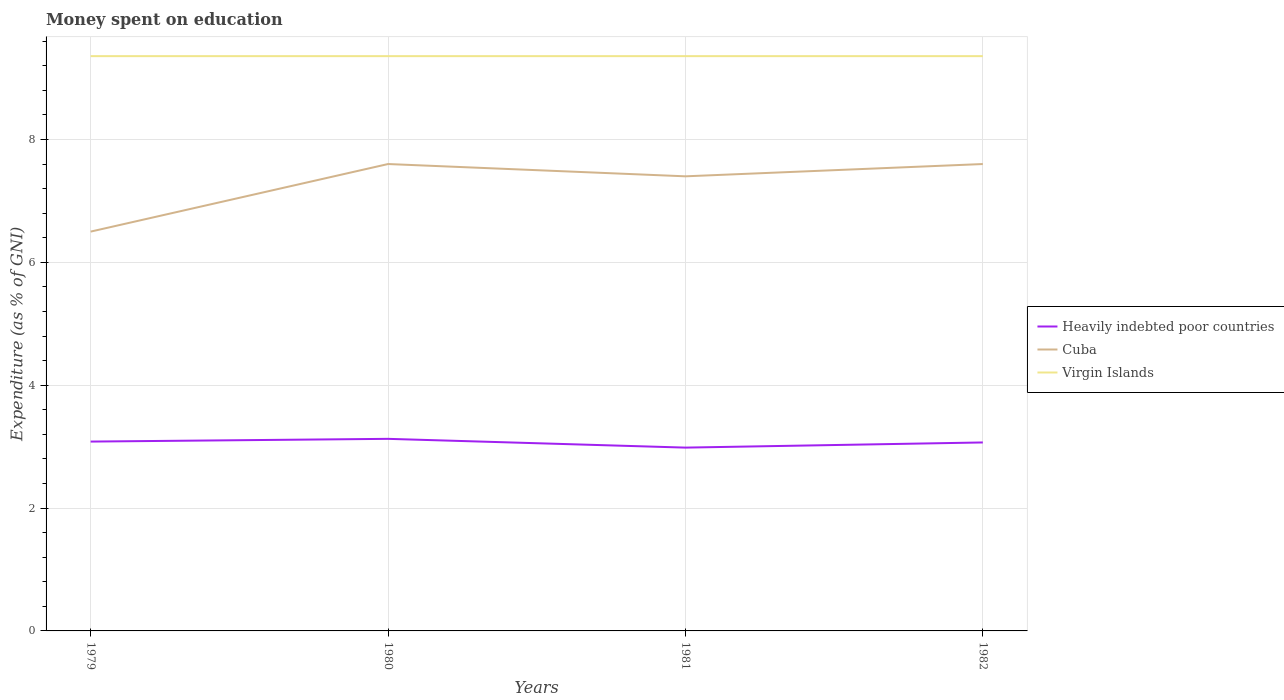What is the total amount of money spent on education in Heavily indebted poor countries in the graph?
Give a very brief answer. 0.14. Is the amount of money spent on education in Heavily indebted poor countries strictly greater than the amount of money spent on education in Cuba over the years?
Your answer should be compact. Yes. How many lines are there?
Your response must be concise. 3. How many years are there in the graph?
Make the answer very short. 4. What is the difference between two consecutive major ticks on the Y-axis?
Keep it short and to the point. 2. Does the graph contain grids?
Your answer should be compact. Yes. How are the legend labels stacked?
Your answer should be very brief. Vertical. What is the title of the graph?
Give a very brief answer. Money spent on education. Does "Bolivia" appear as one of the legend labels in the graph?
Ensure brevity in your answer.  No. What is the label or title of the X-axis?
Offer a very short reply. Years. What is the label or title of the Y-axis?
Your answer should be very brief. Expenditure (as % of GNI). What is the Expenditure (as % of GNI) in Heavily indebted poor countries in 1979?
Your answer should be compact. 3.08. What is the Expenditure (as % of GNI) of Virgin Islands in 1979?
Your response must be concise. 9.36. What is the Expenditure (as % of GNI) of Heavily indebted poor countries in 1980?
Your response must be concise. 3.13. What is the Expenditure (as % of GNI) in Cuba in 1980?
Your answer should be compact. 7.6. What is the Expenditure (as % of GNI) in Virgin Islands in 1980?
Provide a short and direct response. 9.36. What is the Expenditure (as % of GNI) of Heavily indebted poor countries in 1981?
Offer a terse response. 2.98. What is the Expenditure (as % of GNI) in Virgin Islands in 1981?
Give a very brief answer. 9.36. What is the Expenditure (as % of GNI) of Heavily indebted poor countries in 1982?
Provide a succinct answer. 3.07. What is the Expenditure (as % of GNI) of Virgin Islands in 1982?
Your answer should be compact. 9.36. Across all years, what is the maximum Expenditure (as % of GNI) in Heavily indebted poor countries?
Give a very brief answer. 3.13. Across all years, what is the maximum Expenditure (as % of GNI) in Cuba?
Offer a very short reply. 7.6. Across all years, what is the maximum Expenditure (as % of GNI) in Virgin Islands?
Make the answer very short. 9.36. Across all years, what is the minimum Expenditure (as % of GNI) in Heavily indebted poor countries?
Ensure brevity in your answer.  2.98. Across all years, what is the minimum Expenditure (as % of GNI) of Cuba?
Provide a short and direct response. 6.5. Across all years, what is the minimum Expenditure (as % of GNI) in Virgin Islands?
Your answer should be very brief. 9.36. What is the total Expenditure (as % of GNI) of Heavily indebted poor countries in the graph?
Offer a very short reply. 12.26. What is the total Expenditure (as % of GNI) of Cuba in the graph?
Provide a short and direct response. 29.1. What is the total Expenditure (as % of GNI) in Virgin Islands in the graph?
Provide a succinct answer. 37.42. What is the difference between the Expenditure (as % of GNI) in Heavily indebted poor countries in 1979 and that in 1980?
Provide a short and direct response. -0.04. What is the difference between the Expenditure (as % of GNI) in Cuba in 1979 and that in 1980?
Provide a short and direct response. -1.1. What is the difference between the Expenditure (as % of GNI) in Virgin Islands in 1979 and that in 1980?
Offer a terse response. 0. What is the difference between the Expenditure (as % of GNI) of Heavily indebted poor countries in 1979 and that in 1981?
Ensure brevity in your answer.  0.1. What is the difference between the Expenditure (as % of GNI) in Cuba in 1979 and that in 1981?
Make the answer very short. -0.9. What is the difference between the Expenditure (as % of GNI) in Virgin Islands in 1979 and that in 1981?
Ensure brevity in your answer.  0. What is the difference between the Expenditure (as % of GNI) in Heavily indebted poor countries in 1979 and that in 1982?
Provide a short and direct response. 0.01. What is the difference between the Expenditure (as % of GNI) in Cuba in 1979 and that in 1982?
Your response must be concise. -1.1. What is the difference between the Expenditure (as % of GNI) in Heavily indebted poor countries in 1980 and that in 1981?
Make the answer very short. 0.14. What is the difference between the Expenditure (as % of GNI) in Cuba in 1980 and that in 1981?
Offer a very short reply. 0.2. What is the difference between the Expenditure (as % of GNI) of Heavily indebted poor countries in 1980 and that in 1982?
Your response must be concise. 0.06. What is the difference between the Expenditure (as % of GNI) in Virgin Islands in 1980 and that in 1982?
Offer a terse response. 0. What is the difference between the Expenditure (as % of GNI) of Heavily indebted poor countries in 1981 and that in 1982?
Your answer should be compact. -0.08. What is the difference between the Expenditure (as % of GNI) in Cuba in 1981 and that in 1982?
Ensure brevity in your answer.  -0.2. What is the difference between the Expenditure (as % of GNI) of Virgin Islands in 1981 and that in 1982?
Ensure brevity in your answer.  0. What is the difference between the Expenditure (as % of GNI) of Heavily indebted poor countries in 1979 and the Expenditure (as % of GNI) of Cuba in 1980?
Make the answer very short. -4.52. What is the difference between the Expenditure (as % of GNI) of Heavily indebted poor countries in 1979 and the Expenditure (as % of GNI) of Virgin Islands in 1980?
Provide a short and direct response. -6.27. What is the difference between the Expenditure (as % of GNI) of Cuba in 1979 and the Expenditure (as % of GNI) of Virgin Islands in 1980?
Give a very brief answer. -2.86. What is the difference between the Expenditure (as % of GNI) in Heavily indebted poor countries in 1979 and the Expenditure (as % of GNI) in Cuba in 1981?
Keep it short and to the point. -4.32. What is the difference between the Expenditure (as % of GNI) in Heavily indebted poor countries in 1979 and the Expenditure (as % of GNI) in Virgin Islands in 1981?
Your answer should be compact. -6.27. What is the difference between the Expenditure (as % of GNI) in Cuba in 1979 and the Expenditure (as % of GNI) in Virgin Islands in 1981?
Provide a succinct answer. -2.86. What is the difference between the Expenditure (as % of GNI) of Heavily indebted poor countries in 1979 and the Expenditure (as % of GNI) of Cuba in 1982?
Ensure brevity in your answer.  -4.52. What is the difference between the Expenditure (as % of GNI) of Heavily indebted poor countries in 1979 and the Expenditure (as % of GNI) of Virgin Islands in 1982?
Offer a very short reply. -6.27. What is the difference between the Expenditure (as % of GNI) in Cuba in 1979 and the Expenditure (as % of GNI) in Virgin Islands in 1982?
Keep it short and to the point. -2.86. What is the difference between the Expenditure (as % of GNI) in Heavily indebted poor countries in 1980 and the Expenditure (as % of GNI) in Cuba in 1981?
Keep it short and to the point. -4.27. What is the difference between the Expenditure (as % of GNI) in Heavily indebted poor countries in 1980 and the Expenditure (as % of GNI) in Virgin Islands in 1981?
Provide a short and direct response. -6.23. What is the difference between the Expenditure (as % of GNI) of Cuba in 1980 and the Expenditure (as % of GNI) of Virgin Islands in 1981?
Your answer should be compact. -1.76. What is the difference between the Expenditure (as % of GNI) in Heavily indebted poor countries in 1980 and the Expenditure (as % of GNI) in Cuba in 1982?
Give a very brief answer. -4.47. What is the difference between the Expenditure (as % of GNI) in Heavily indebted poor countries in 1980 and the Expenditure (as % of GNI) in Virgin Islands in 1982?
Your answer should be very brief. -6.23. What is the difference between the Expenditure (as % of GNI) in Cuba in 1980 and the Expenditure (as % of GNI) in Virgin Islands in 1982?
Offer a very short reply. -1.76. What is the difference between the Expenditure (as % of GNI) of Heavily indebted poor countries in 1981 and the Expenditure (as % of GNI) of Cuba in 1982?
Offer a very short reply. -4.62. What is the difference between the Expenditure (as % of GNI) in Heavily indebted poor countries in 1981 and the Expenditure (as % of GNI) in Virgin Islands in 1982?
Your response must be concise. -6.37. What is the difference between the Expenditure (as % of GNI) of Cuba in 1981 and the Expenditure (as % of GNI) of Virgin Islands in 1982?
Offer a terse response. -1.96. What is the average Expenditure (as % of GNI) of Heavily indebted poor countries per year?
Give a very brief answer. 3.07. What is the average Expenditure (as % of GNI) of Cuba per year?
Keep it short and to the point. 7.28. What is the average Expenditure (as % of GNI) in Virgin Islands per year?
Provide a short and direct response. 9.36. In the year 1979, what is the difference between the Expenditure (as % of GNI) in Heavily indebted poor countries and Expenditure (as % of GNI) in Cuba?
Give a very brief answer. -3.42. In the year 1979, what is the difference between the Expenditure (as % of GNI) of Heavily indebted poor countries and Expenditure (as % of GNI) of Virgin Islands?
Your answer should be compact. -6.27. In the year 1979, what is the difference between the Expenditure (as % of GNI) of Cuba and Expenditure (as % of GNI) of Virgin Islands?
Give a very brief answer. -2.86. In the year 1980, what is the difference between the Expenditure (as % of GNI) of Heavily indebted poor countries and Expenditure (as % of GNI) of Cuba?
Your response must be concise. -4.47. In the year 1980, what is the difference between the Expenditure (as % of GNI) in Heavily indebted poor countries and Expenditure (as % of GNI) in Virgin Islands?
Offer a terse response. -6.23. In the year 1980, what is the difference between the Expenditure (as % of GNI) of Cuba and Expenditure (as % of GNI) of Virgin Islands?
Offer a terse response. -1.76. In the year 1981, what is the difference between the Expenditure (as % of GNI) in Heavily indebted poor countries and Expenditure (as % of GNI) in Cuba?
Your answer should be very brief. -4.42. In the year 1981, what is the difference between the Expenditure (as % of GNI) in Heavily indebted poor countries and Expenditure (as % of GNI) in Virgin Islands?
Provide a succinct answer. -6.37. In the year 1981, what is the difference between the Expenditure (as % of GNI) in Cuba and Expenditure (as % of GNI) in Virgin Islands?
Give a very brief answer. -1.96. In the year 1982, what is the difference between the Expenditure (as % of GNI) of Heavily indebted poor countries and Expenditure (as % of GNI) of Cuba?
Your response must be concise. -4.53. In the year 1982, what is the difference between the Expenditure (as % of GNI) of Heavily indebted poor countries and Expenditure (as % of GNI) of Virgin Islands?
Your answer should be very brief. -6.29. In the year 1982, what is the difference between the Expenditure (as % of GNI) in Cuba and Expenditure (as % of GNI) in Virgin Islands?
Make the answer very short. -1.76. What is the ratio of the Expenditure (as % of GNI) in Heavily indebted poor countries in 1979 to that in 1980?
Provide a short and direct response. 0.99. What is the ratio of the Expenditure (as % of GNI) of Cuba in 1979 to that in 1980?
Provide a succinct answer. 0.86. What is the ratio of the Expenditure (as % of GNI) of Heavily indebted poor countries in 1979 to that in 1981?
Give a very brief answer. 1.03. What is the ratio of the Expenditure (as % of GNI) in Cuba in 1979 to that in 1981?
Provide a succinct answer. 0.88. What is the ratio of the Expenditure (as % of GNI) of Virgin Islands in 1979 to that in 1981?
Ensure brevity in your answer.  1. What is the ratio of the Expenditure (as % of GNI) of Heavily indebted poor countries in 1979 to that in 1982?
Your answer should be very brief. 1. What is the ratio of the Expenditure (as % of GNI) in Cuba in 1979 to that in 1982?
Your response must be concise. 0.86. What is the ratio of the Expenditure (as % of GNI) of Heavily indebted poor countries in 1980 to that in 1981?
Keep it short and to the point. 1.05. What is the ratio of the Expenditure (as % of GNI) in Cuba in 1980 to that in 1981?
Your answer should be compact. 1.03. What is the ratio of the Expenditure (as % of GNI) of Heavily indebted poor countries in 1980 to that in 1982?
Make the answer very short. 1.02. What is the ratio of the Expenditure (as % of GNI) of Heavily indebted poor countries in 1981 to that in 1982?
Give a very brief answer. 0.97. What is the ratio of the Expenditure (as % of GNI) in Cuba in 1981 to that in 1982?
Offer a very short reply. 0.97. What is the ratio of the Expenditure (as % of GNI) of Virgin Islands in 1981 to that in 1982?
Your answer should be very brief. 1. What is the difference between the highest and the second highest Expenditure (as % of GNI) in Heavily indebted poor countries?
Provide a short and direct response. 0.04. What is the difference between the highest and the lowest Expenditure (as % of GNI) of Heavily indebted poor countries?
Offer a very short reply. 0.14. What is the difference between the highest and the lowest Expenditure (as % of GNI) in Cuba?
Provide a succinct answer. 1.1. 